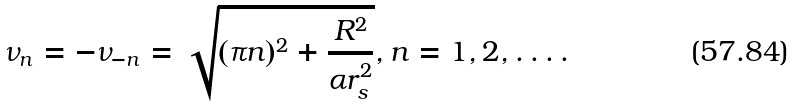Convert formula to latex. <formula><loc_0><loc_0><loc_500><loc_500>\nu _ { n } = - \nu _ { - n } = \sqrt { ( \pi n ) ^ { 2 } + \frac { R ^ { 2 } } { \alpha r _ { s } ^ { 2 } } } , n = 1 , 2 , \dots .</formula> 